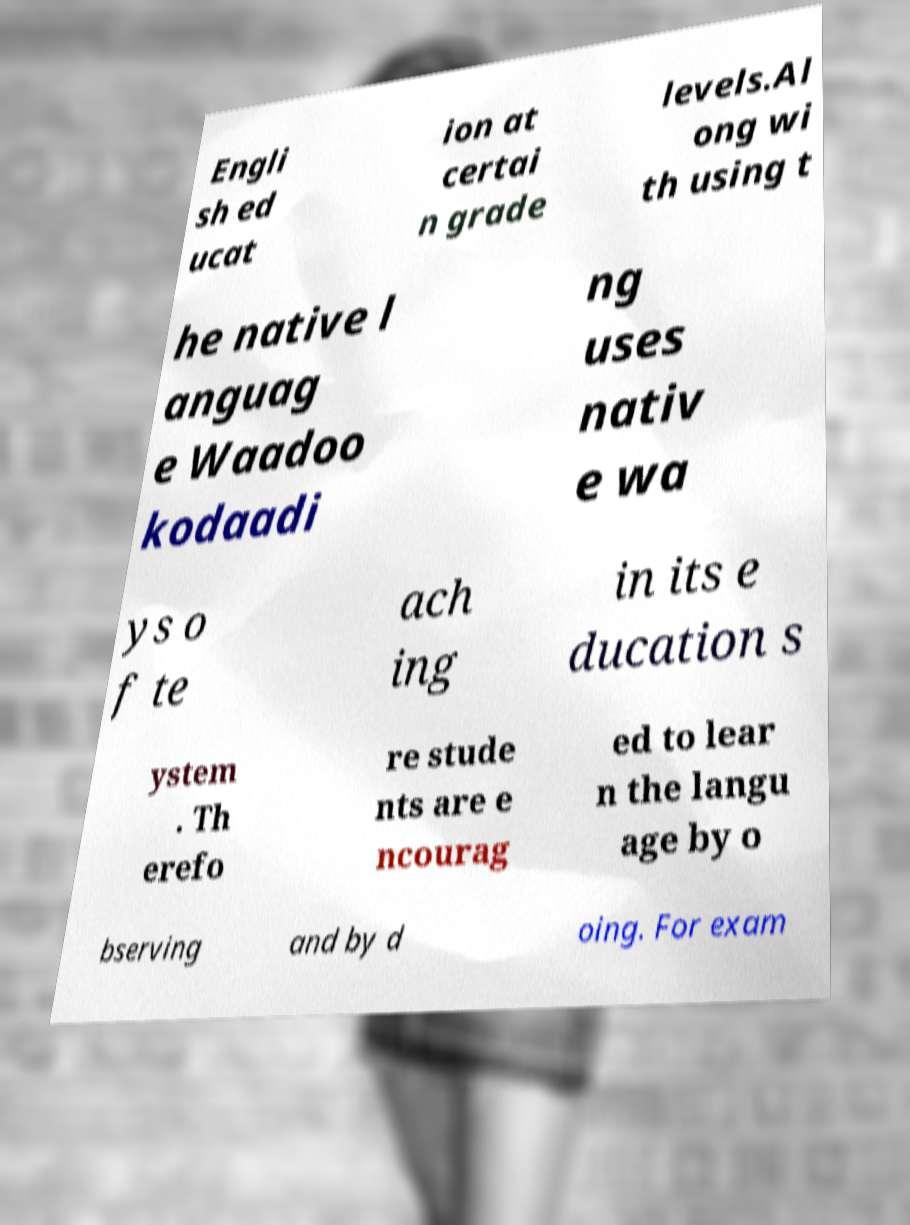I need the written content from this picture converted into text. Can you do that? Engli sh ed ucat ion at certai n grade levels.Al ong wi th using t he native l anguag e Waadoo kodaadi ng uses nativ e wa ys o f te ach ing in its e ducation s ystem . Th erefo re stude nts are e ncourag ed to lear n the langu age by o bserving and by d oing. For exam 